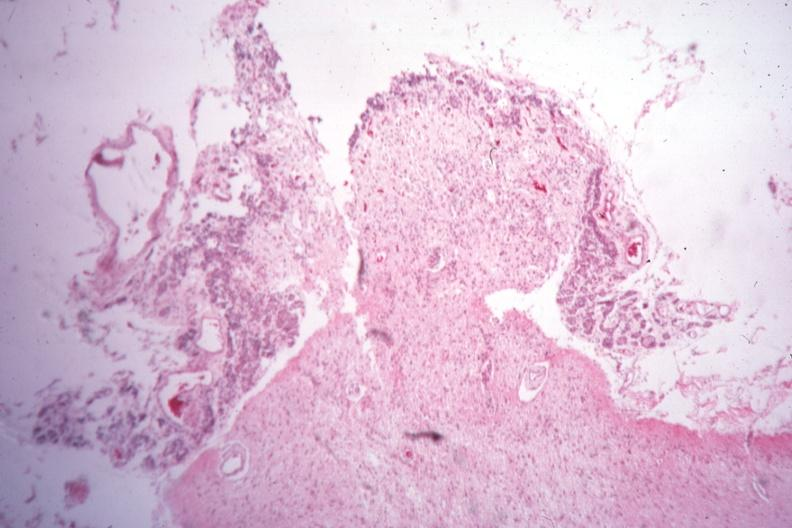what is present?
Answer the question using a single word or phrase. Endocrine 